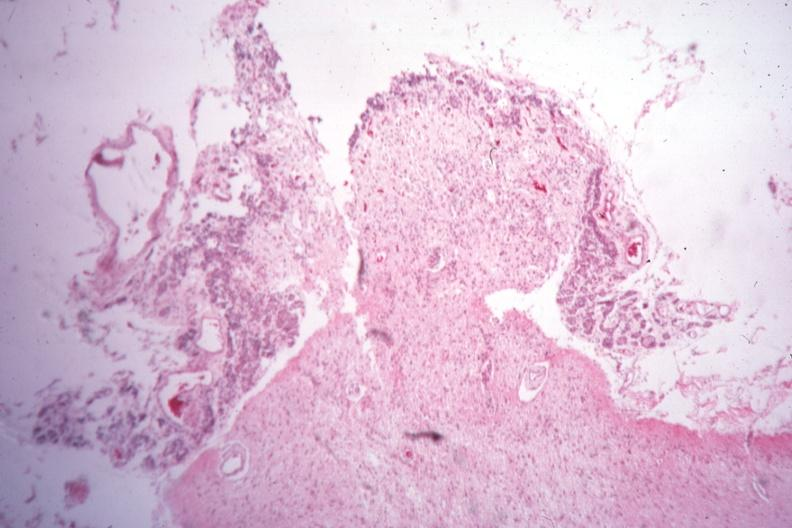what is present?
Answer the question using a single word or phrase. Endocrine 